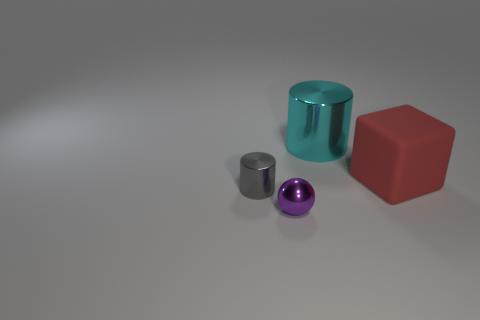Add 3 big red objects. How many objects exist? 7 Subtract all spheres. How many objects are left? 3 Add 1 small gray cylinders. How many small gray cylinders are left? 2 Add 3 small blue rubber objects. How many small blue rubber objects exist? 3 Subtract 0 green cubes. How many objects are left? 4 Subtract all big purple rubber things. Subtract all metal spheres. How many objects are left? 3 